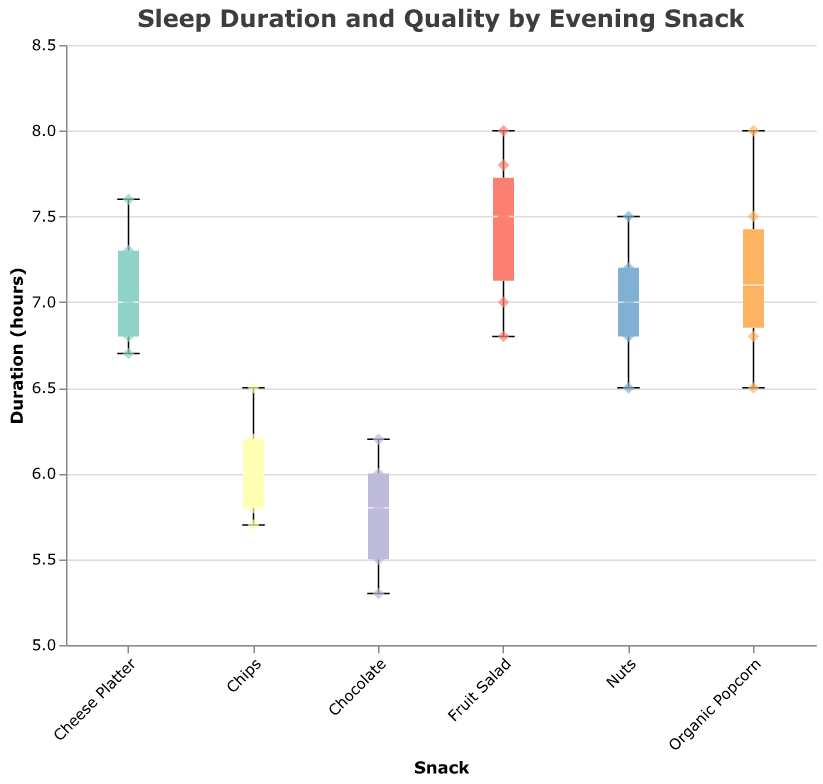What's the title of the figure? The title is displayed prominently at the top of the figure, indicating the overall subject of the plot.
Answer: "Sleep Duration and Quality by Evening Snack" How many data points represent individuals who consumed Organic Popcorn? By counting the scatter points related to the "Organic Popcorn" category, you can determine the number of data points for this snack.
Answer: 6 Which snack has the longest average sleep duration? By comparing the median lines of the box plots for each snack, the snack with the highest median line represents the longest average sleep duration.
Answer: Fruit Salad What is the range of sleep duration for individuals who consumed Chocolate? The range can be identified by looking at the minimum and maximum whiskers of the Chocolate box plot.
Answer: 5.3 to 6.2 hours Compare the sleep quality for Fruit Salad and Chips. Which one leads to a higher sleep quality on average? By looking at the Quality (1-10) values in the scatter points for both snacks, you can determine which group displays higher values more consistently.
Answer: Fruit Salad What is the median sleep duration for those who consumed Nuts? The median sleep duration is represented by the white line inside the Nuts box plot.
Answer: 7 hours Which snack shows the most variation in sleep duration? The variation can be observed by the length of the box plot's interquartile range (IQR) and the whiskers. The longer the IQR and whiskers, the more variation in the data.
Answer: Chips For the Organic Popcorn group, how many individuals reported a sleep quality of 8? Count the number of scatter points for Organic Popcorn that have a Quality (1-10) value of 8.
Answer: 3 Is there any snack where all individuals had a sleep quality lower than 6? Check each snack's scatter points to see if any snack has all points with Quality (1-10) values less than 6.
Answer: No Between Cheese Platter and Nuts, which one has individuals with the highest maximum sleep duration? Compare the maximum whisker lengths of the box plots for Cheese Platter and Nuts.
Answer: Cheese Platter 